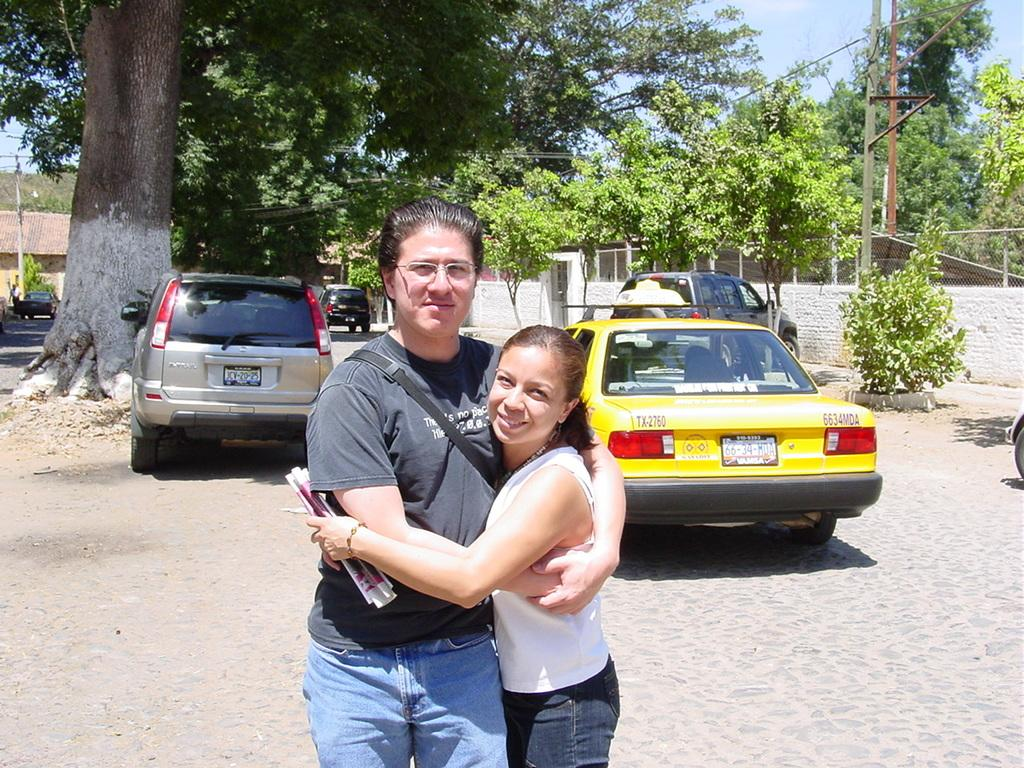<image>
Write a terse but informative summary of the picture. a car that has the numbers 66 on the back 